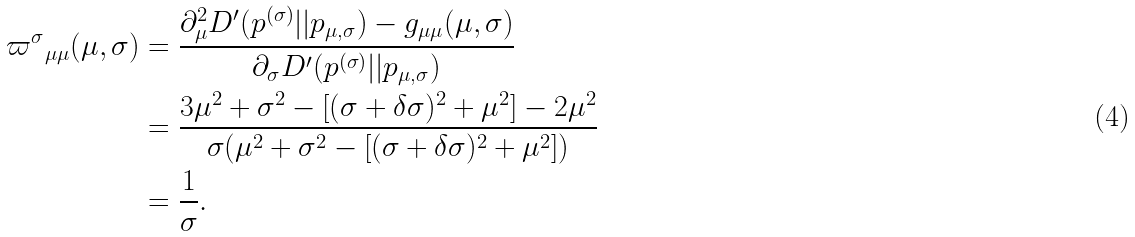<formula> <loc_0><loc_0><loc_500><loc_500>{ \varpi ^ { \sigma } } _ { \mu \mu } ( \mu , \sigma ) & = \frac { \partial _ { \mu } ^ { 2 } D ^ { \prime } ( p ^ { ( \sigma ) } | | p _ { \mu , \sigma } ) - g _ { \mu \mu } ( \mu , \sigma ) } { \partial _ { \sigma } D ^ { \prime } ( p ^ { ( \sigma ) } | | p _ { \mu , \sigma } ) } \\ & = \frac { 3 \mu ^ { 2 } + \sigma ^ { 2 } - [ ( \sigma + \delta \sigma ) ^ { 2 } + \mu ^ { 2 } ] - 2 \mu ^ { 2 } } { \sigma ( \mu ^ { 2 } + \sigma ^ { 2 } - [ ( \sigma + \delta \sigma ) ^ { 2 } + \mu ^ { 2 } ] ) } \\ & = \frac { 1 } { \sigma } .</formula> 